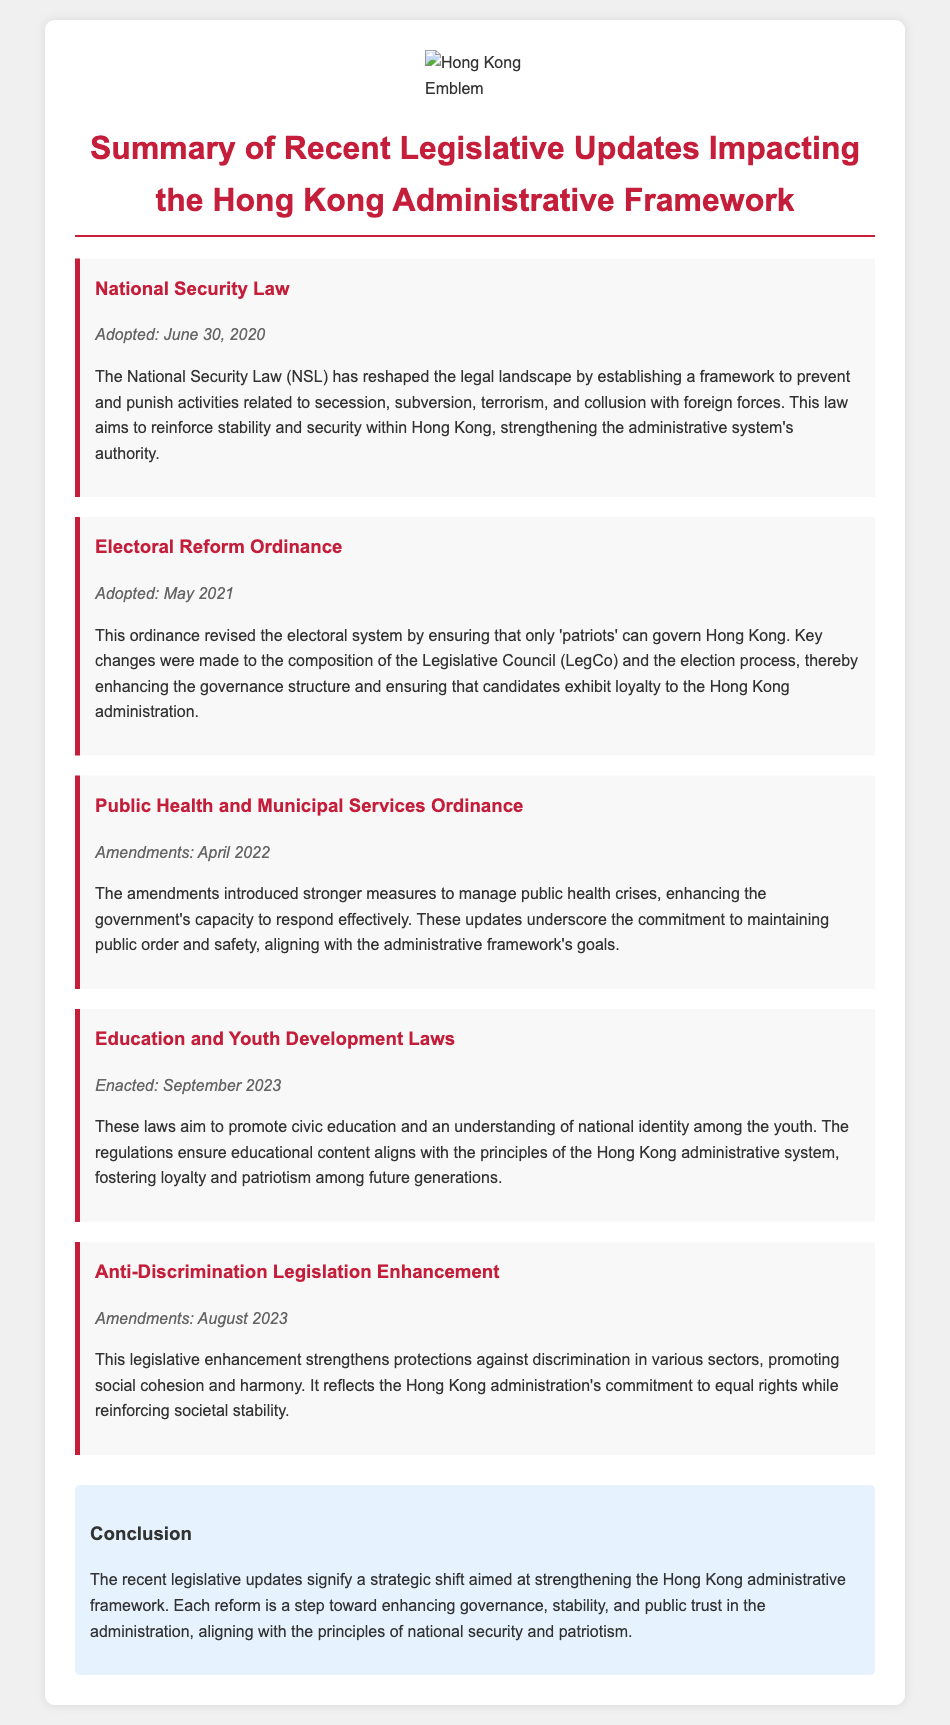what law was adopted on June 30, 2020? The document mentions that the National Security Law was adopted on this date, which has implications for the legal landscape in Hong Kong.
Answer: National Security Law when was the Electoral Reform Ordinance enacted? The document specifies that the Electoral Reform Ordinance was adopted in May 2021, changing the electoral system in Hong Kong.
Answer: May 2021 what is the main focus of the amendments made in the Public Health and Municipal Services Ordinance? According to the document, the amendments aimed to enhance the government's capacity to manage public health crises, which reflects its objective.
Answer: Public health crises what do the Education and Youth Development Laws promote? The document states that these laws aim to promote civic education and national identity understanding among the youth in Hong Kong.
Answer: Civic education and national identity how does the Anti-Discrimination Legislation Enhancement affect societal cohesion? The document explains that this enhancement strengthens protections against discrimination, which promotes social cohesion and harmony in Hong Kong.
Answer: Social cohesion and harmony what is the conclusion about the recent legislative updates? The conclusion in the document emphasizes that these updates signify a strategic shift to strengthen the Hong Kong administrative framework and enhance governance.
Answer: Strategic shift how many reforms are listed in the document? A count of the reforms mentioned in the document reveals that there are five distinct reforms highlighted.
Answer: Five what does the National Security Law establish? The document indicates that the National Security Law establishes a framework to prevent and punish activities related to secession and other threats to security.
Answer: Framework for security-related activities 